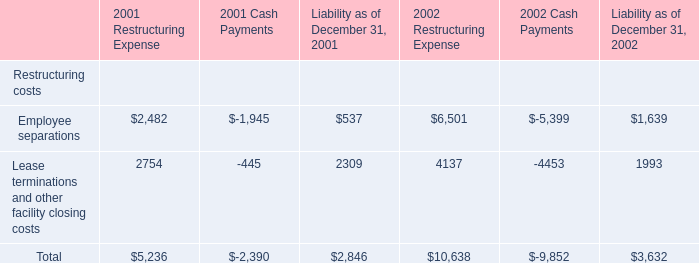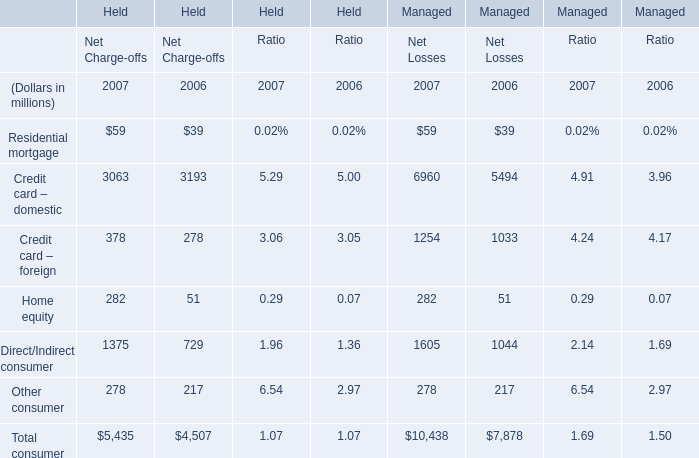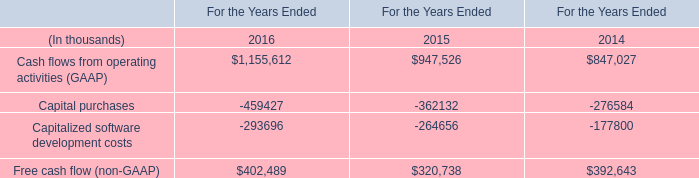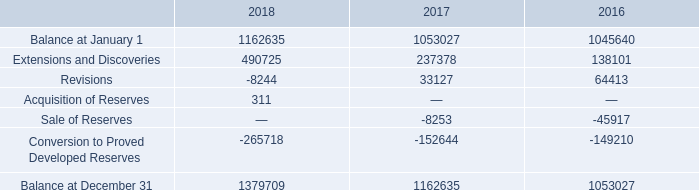what was the increase observed in the initial balance between 2017 and 2018? 
Computations: ((1162635 / 1053027) - 1)
Answer: 0.10409. 